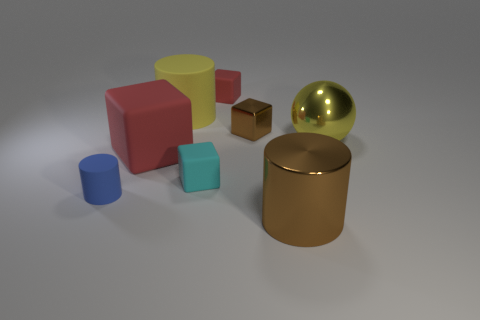How many cylinders are there?
Offer a very short reply. 3. Is the material of the small cylinder the same as the big object that is right of the big brown metal cylinder?
Your response must be concise. No. What number of gray objects are either tiny cubes or big cylinders?
Offer a terse response. 0. What is the size of the cyan object that is made of the same material as the small blue cylinder?
Offer a very short reply. Small. How many tiny gray metallic objects are the same shape as the tiny brown shiny thing?
Offer a terse response. 0. Are there more small matte cylinders in front of the cyan matte block than rubber objects that are to the left of the blue matte cylinder?
Ensure brevity in your answer.  Yes. Do the big metallic ball and the tiny matte thing that is to the left of the big rubber cube have the same color?
Your answer should be very brief. No. What material is the brown object that is the same size as the cyan rubber block?
Provide a succinct answer. Metal. How many things are either large yellow blocks or tiny matte objects that are to the left of the big yellow cylinder?
Provide a succinct answer. 1. Does the yellow metal object have the same size as the shiny object in front of the blue cylinder?
Offer a very short reply. Yes. 